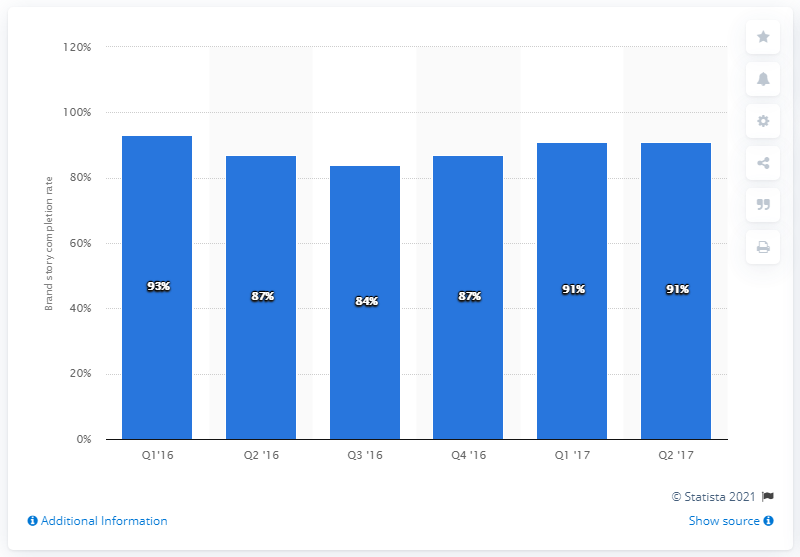Draw attention to some important aspects in this diagram. As of the last measured period, the overall brand story completion rate was 91%. 